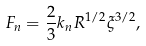<formula> <loc_0><loc_0><loc_500><loc_500>F _ { n } = \frac { 2 } { 3 } k _ { n } R ^ { 1 / 2 } \xi ^ { 3 / 2 } ,</formula> 